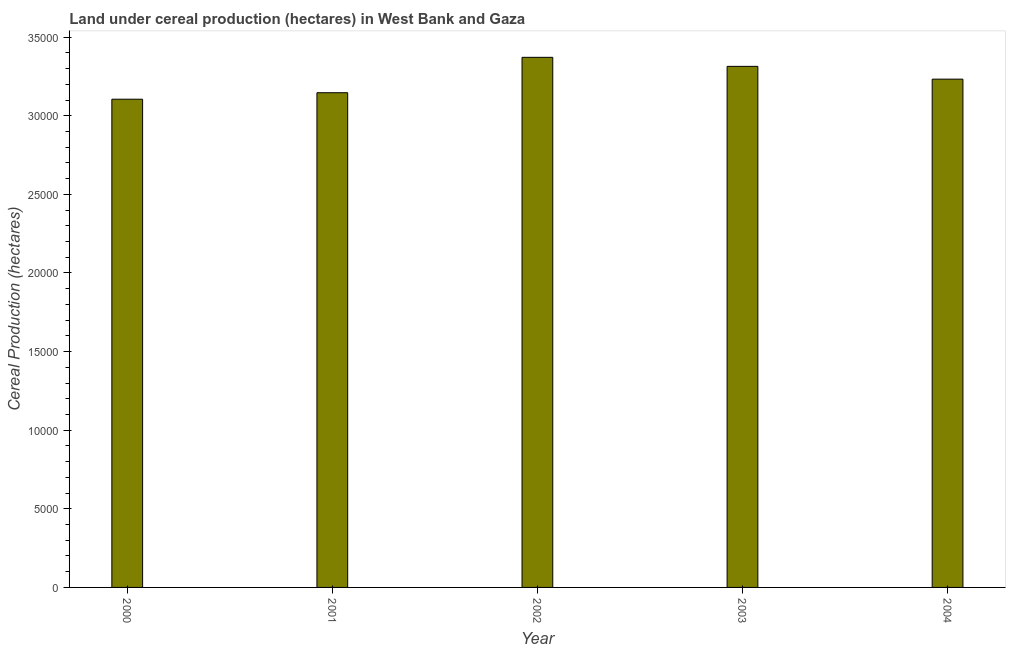Does the graph contain any zero values?
Your response must be concise. No. Does the graph contain grids?
Your response must be concise. No. What is the title of the graph?
Offer a terse response. Land under cereal production (hectares) in West Bank and Gaza. What is the label or title of the X-axis?
Offer a very short reply. Year. What is the label or title of the Y-axis?
Your response must be concise. Cereal Production (hectares). What is the land under cereal production in 2004?
Provide a short and direct response. 3.23e+04. Across all years, what is the maximum land under cereal production?
Ensure brevity in your answer.  3.37e+04. Across all years, what is the minimum land under cereal production?
Make the answer very short. 3.11e+04. In which year was the land under cereal production minimum?
Make the answer very short. 2000. What is the sum of the land under cereal production?
Your answer should be very brief. 1.62e+05. What is the difference between the land under cereal production in 2003 and 2004?
Provide a succinct answer. 813. What is the average land under cereal production per year?
Ensure brevity in your answer.  3.23e+04. What is the median land under cereal production?
Your response must be concise. 3.23e+04. What is the ratio of the land under cereal production in 2000 to that in 2001?
Your answer should be compact. 0.99. Is the land under cereal production in 2000 less than that in 2004?
Keep it short and to the point. Yes. What is the difference between the highest and the second highest land under cereal production?
Ensure brevity in your answer.  575. Is the sum of the land under cereal production in 2002 and 2003 greater than the maximum land under cereal production across all years?
Ensure brevity in your answer.  Yes. What is the difference between the highest and the lowest land under cereal production?
Provide a succinct answer. 2664. In how many years, is the land under cereal production greater than the average land under cereal production taken over all years?
Provide a succinct answer. 2. Are all the bars in the graph horizontal?
Provide a succinct answer. No. What is the difference between two consecutive major ticks on the Y-axis?
Your response must be concise. 5000. What is the Cereal Production (hectares) in 2000?
Provide a succinct answer. 3.11e+04. What is the Cereal Production (hectares) of 2001?
Make the answer very short. 3.15e+04. What is the Cereal Production (hectares) in 2002?
Make the answer very short. 3.37e+04. What is the Cereal Production (hectares) of 2003?
Offer a very short reply. 3.31e+04. What is the Cereal Production (hectares) of 2004?
Make the answer very short. 3.23e+04. What is the difference between the Cereal Production (hectares) in 2000 and 2001?
Make the answer very short. -413. What is the difference between the Cereal Production (hectares) in 2000 and 2002?
Offer a terse response. -2664. What is the difference between the Cereal Production (hectares) in 2000 and 2003?
Provide a succinct answer. -2089. What is the difference between the Cereal Production (hectares) in 2000 and 2004?
Provide a short and direct response. -1276. What is the difference between the Cereal Production (hectares) in 2001 and 2002?
Your answer should be very brief. -2251. What is the difference between the Cereal Production (hectares) in 2001 and 2003?
Offer a very short reply. -1676. What is the difference between the Cereal Production (hectares) in 2001 and 2004?
Provide a succinct answer. -863. What is the difference between the Cereal Production (hectares) in 2002 and 2003?
Give a very brief answer. 575. What is the difference between the Cereal Production (hectares) in 2002 and 2004?
Your answer should be compact. 1388. What is the difference between the Cereal Production (hectares) in 2003 and 2004?
Ensure brevity in your answer.  813. What is the ratio of the Cereal Production (hectares) in 2000 to that in 2002?
Your response must be concise. 0.92. What is the ratio of the Cereal Production (hectares) in 2000 to that in 2003?
Keep it short and to the point. 0.94. What is the ratio of the Cereal Production (hectares) in 2000 to that in 2004?
Your response must be concise. 0.96. What is the ratio of the Cereal Production (hectares) in 2001 to that in 2002?
Give a very brief answer. 0.93. What is the ratio of the Cereal Production (hectares) in 2001 to that in 2003?
Give a very brief answer. 0.95. What is the ratio of the Cereal Production (hectares) in 2001 to that in 2004?
Your response must be concise. 0.97. What is the ratio of the Cereal Production (hectares) in 2002 to that in 2003?
Your answer should be compact. 1.02. What is the ratio of the Cereal Production (hectares) in 2002 to that in 2004?
Your answer should be compact. 1.04. What is the ratio of the Cereal Production (hectares) in 2003 to that in 2004?
Offer a very short reply. 1.02. 